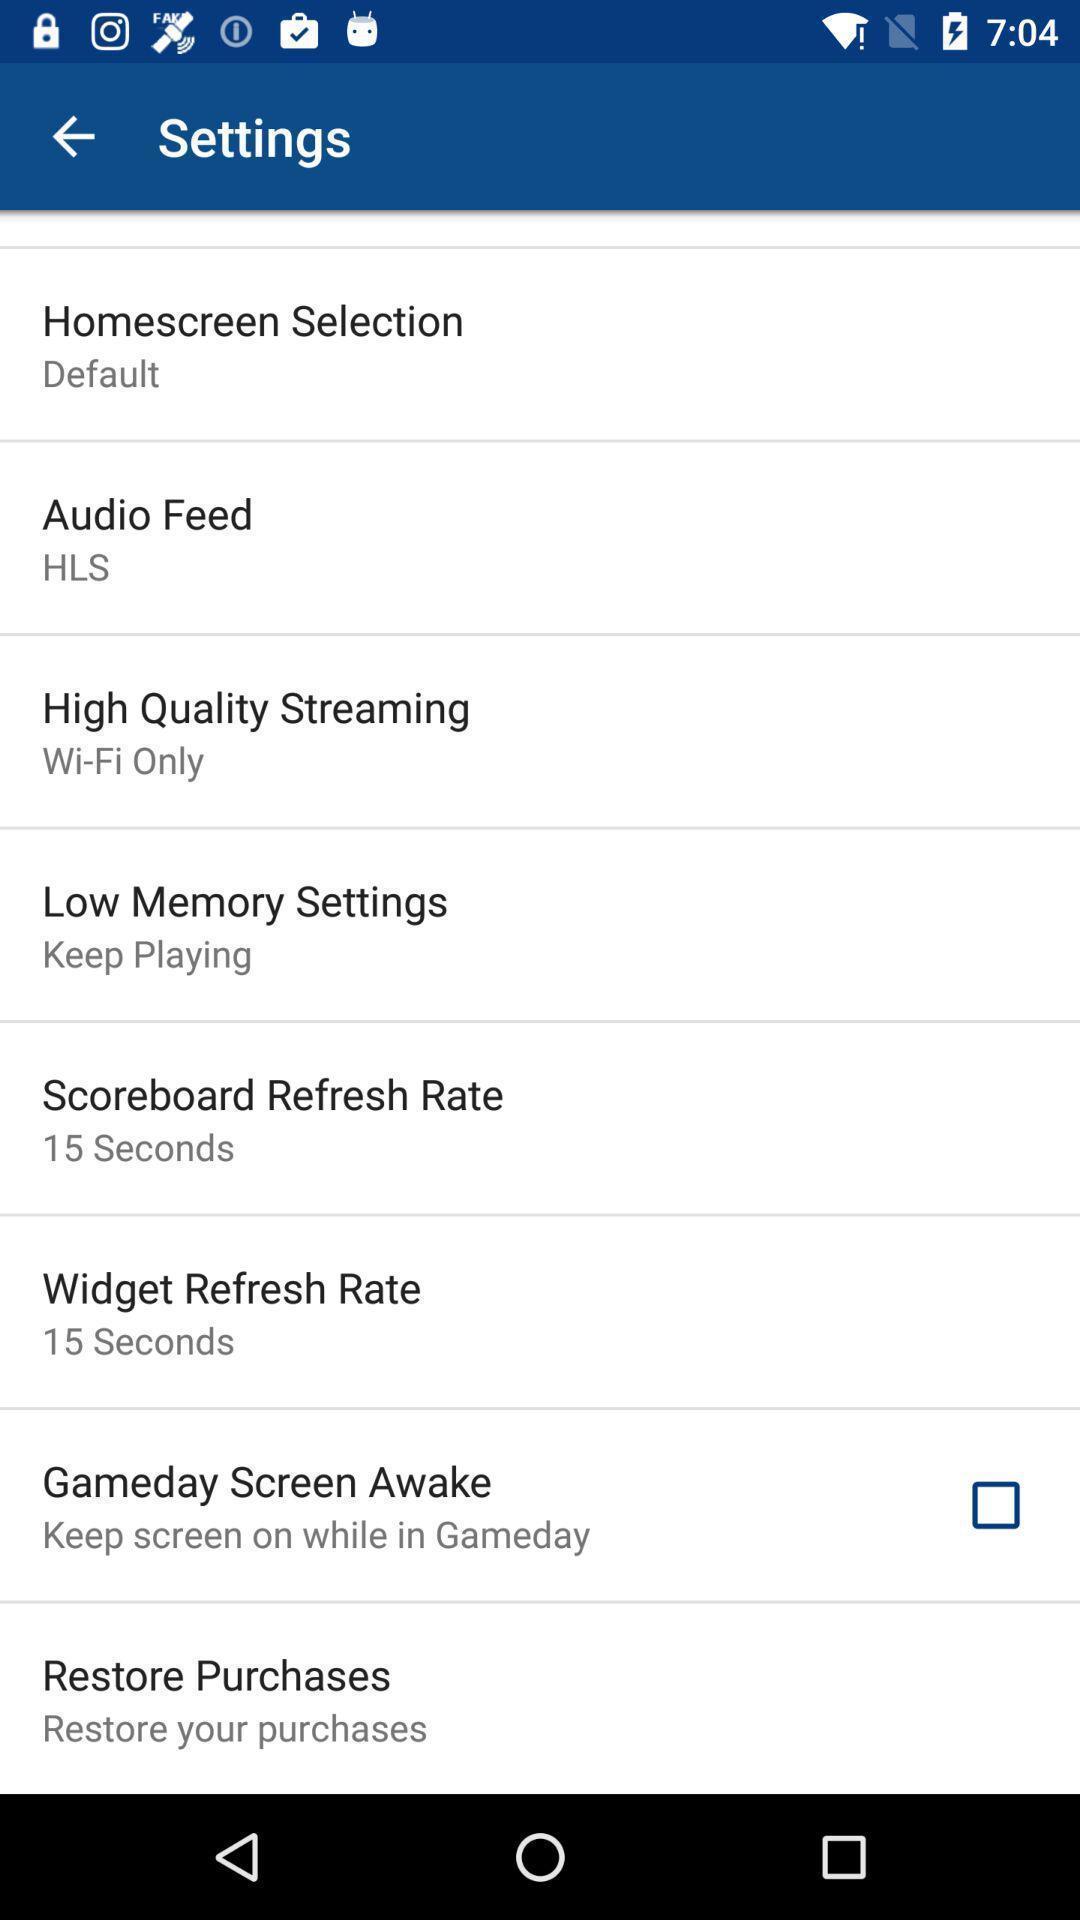Describe the content in this image. Settings page. 